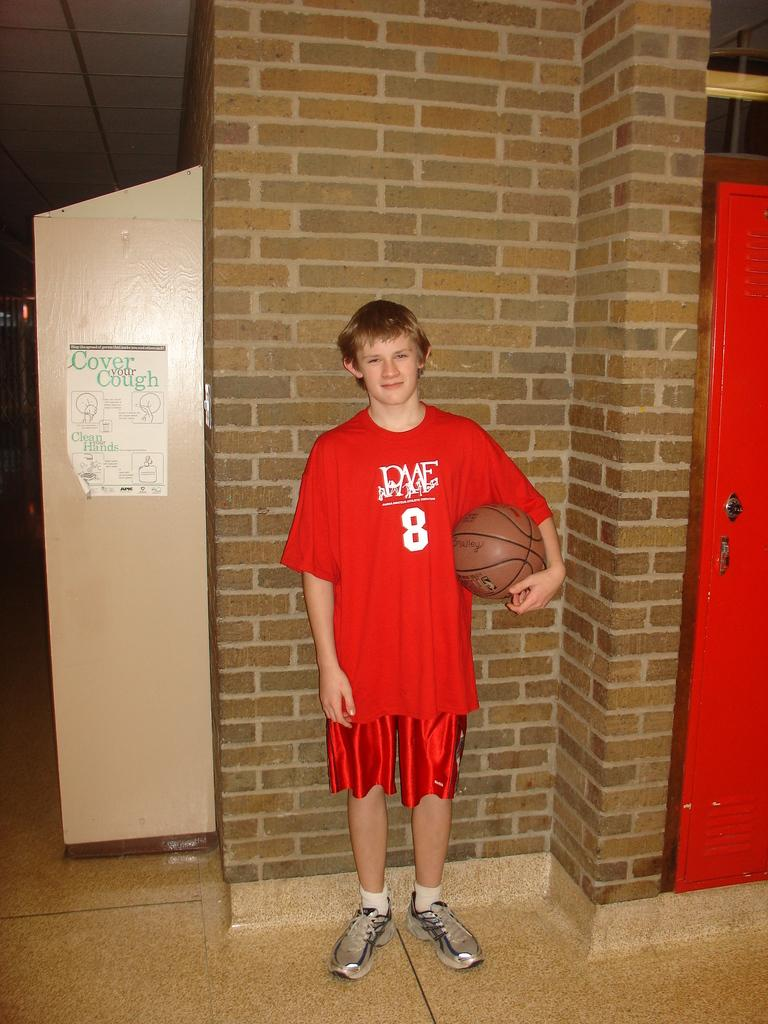<image>
Summarize the visual content of the image. the shirt of a boy has the number 8 on it 